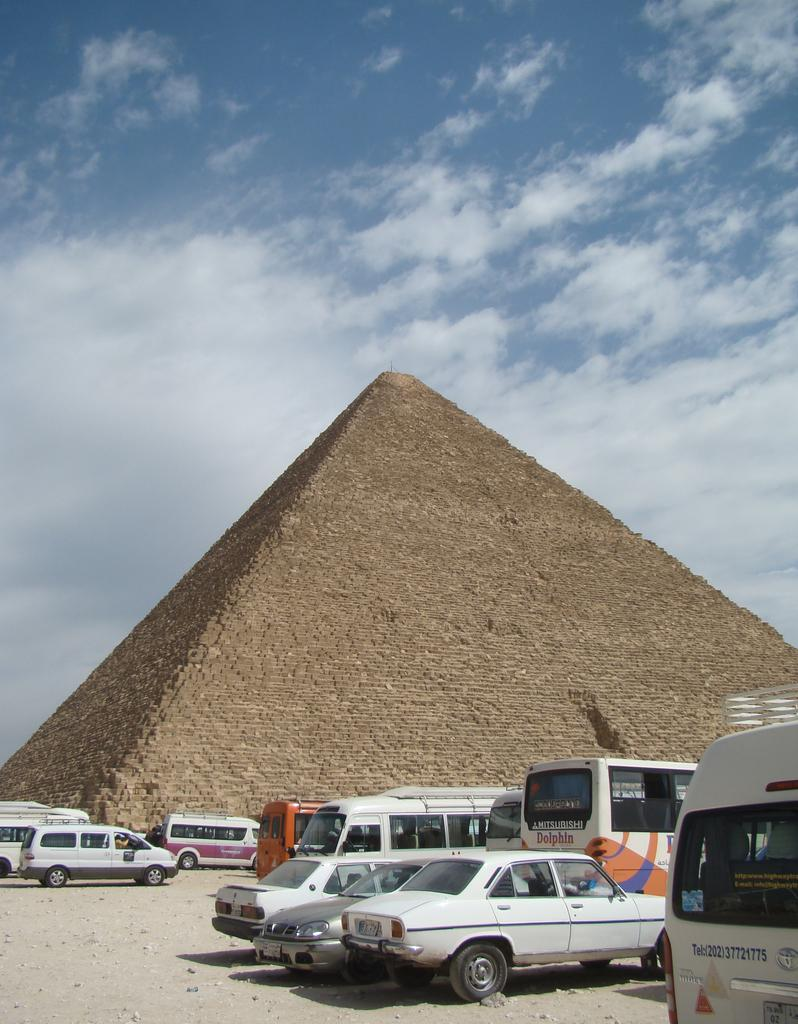What is the main structure in the image? There is a pyramid in the image. What else can be seen at the bottom of the image? There are cars at the bottom of the image. What is visible at the top of the image? Clouds are visible at the top of the image. What type of bat is flying near the pyramid in the image? There is no bat present in the image. Can you describe the facial expression of the pyramid in the image? The pyramid is a structure and does not have a face or facial expression. 